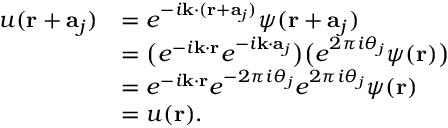<formula> <loc_0><loc_0><loc_500><loc_500>{ \begin{array} { r l } { u ( r + a _ { j } ) } & { = e ^ { - i k \cdot ( r + a _ { j } ) } \psi ( r + a _ { j } ) } \\ & { = { \left ( } e ^ { - i k \cdot r } e ^ { - i k \cdot a _ { j } } { \right ) } { \left ( } e ^ { 2 \pi i \theta _ { j } } \psi ( r ) { \right ) } } \\ & { = e ^ { - i k \cdot r } e ^ { - 2 \pi i \theta _ { j } } e ^ { 2 \pi i \theta _ { j } } \psi ( r ) } \\ & { = u ( r ) . } \end{array} }</formula> 